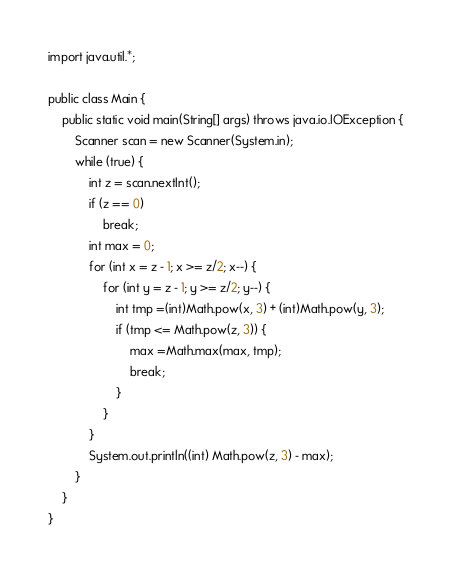Convert code to text. <code><loc_0><loc_0><loc_500><loc_500><_Java_>import java.util.*;

public class Main {
    public static void main(String[] args) throws java.io.IOException {
        Scanner scan = new Scanner(System.in);
        while (true) {
            int z = scan.nextInt();
            if (z == 0)
                break;
            int max = 0;
            for (int x = z - 1; x >= z/2; x--) {
                for (int y = z - 1; y >= z/2; y--) {
                    int tmp =(int)Math.pow(x, 3) + (int)Math.pow(y, 3);
                    if (tmp <= Math.pow(z, 3)) {
                        max =Math.max(max, tmp);
                        break;
                    }
                }
            }
            System.out.println((int) Math.pow(z, 3) - max);
        }
    }
}</code> 